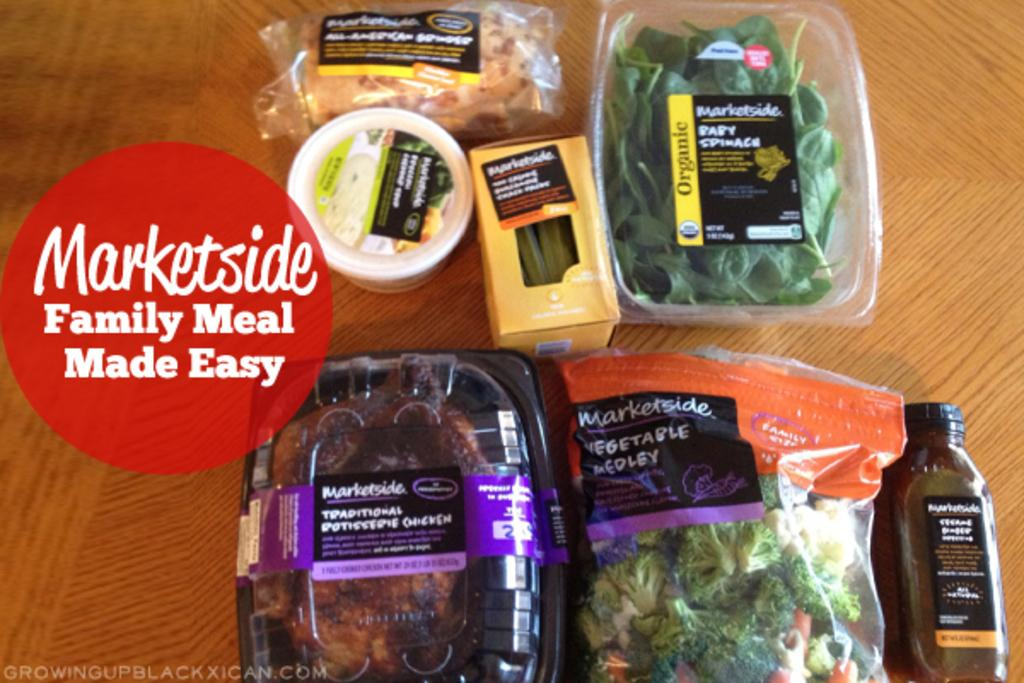<image>
Share a concise interpretation of the image provided. A advertisement for Marketside family meals claims to be easy. 